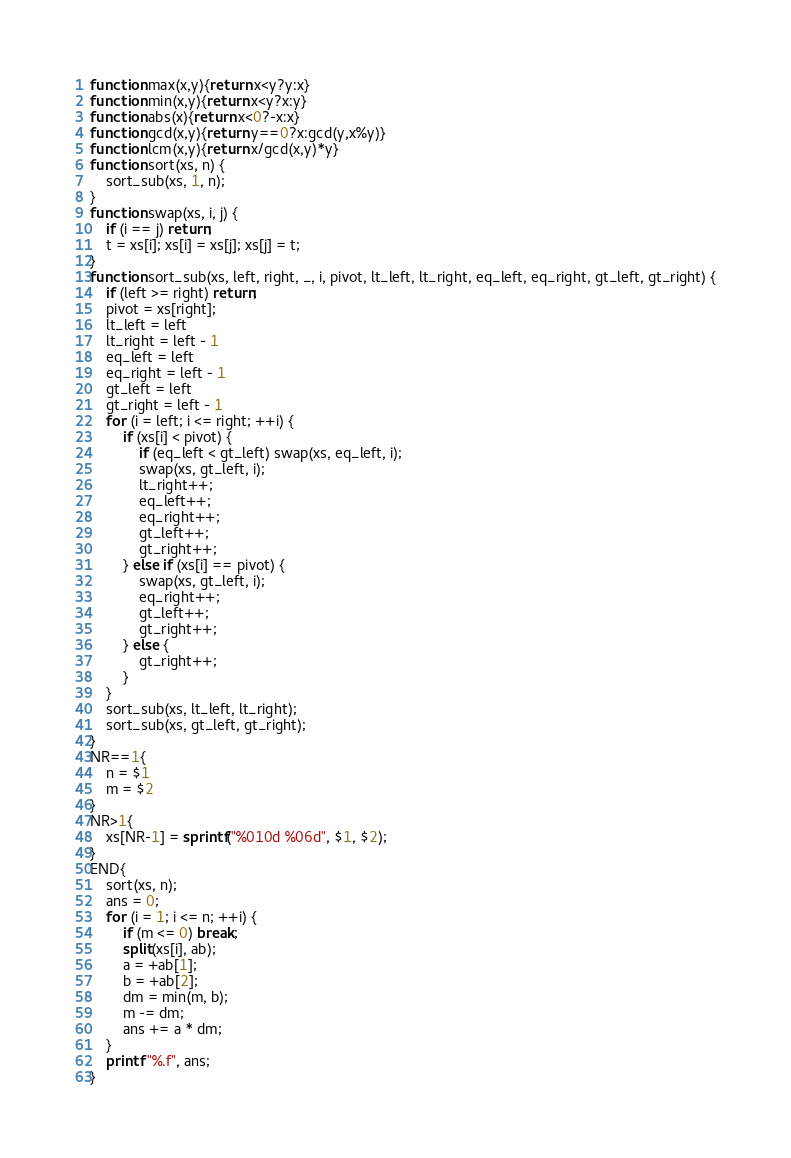Convert code to text. <code><loc_0><loc_0><loc_500><loc_500><_Awk_>function max(x,y){return x<y?y:x}
function min(x,y){return x<y?x:y}
function abs(x){return x<0?-x:x}
function gcd(x,y){return y==0?x:gcd(y,x%y)}
function lcm(x,y){return x/gcd(x,y)*y}
function sort(xs, n) {
    sort_sub(xs, 1, n);
}
function swap(xs, i, j) {
    if (i == j) return;
    t = xs[i]; xs[i] = xs[j]; xs[j] = t;
}
function sort_sub(xs, left, right, _, i, pivot, lt_left, lt_right, eq_left, eq_right, gt_left, gt_right) {
    if (left >= right) return;
    pivot = xs[right];
    lt_left = left
    lt_right = left - 1
    eq_left = left
    eq_right = left - 1
    gt_left = left
    gt_right = left - 1
    for (i = left; i <= right; ++i) {
        if (xs[i] < pivot) {
            if (eq_left < gt_left) swap(xs, eq_left, i);
            swap(xs, gt_left, i);
            lt_right++;
            eq_left++;
            eq_right++;
            gt_left++;
            gt_right++;
        } else if (xs[i] == pivot) {
            swap(xs, gt_left, i);
            eq_right++;
            gt_left++;
            gt_right++;
        } else {
            gt_right++;
        }
    }
    sort_sub(xs, lt_left, lt_right);
    sort_sub(xs, gt_left, gt_right);
}
NR==1{
    n = $1
    m = $2
}
NR>1{
    xs[NR-1] = sprintf("%010d %06d", $1, $2);
}
END{
    sort(xs, n);
    ans = 0;
    for (i = 1; i <= n; ++i) {
        if (m <= 0) break;
        split(xs[i], ab);
        a = +ab[1];
        b = +ab[2];
        dm = min(m, b);
        m -= dm;
        ans += a * dm;
    }
    printf "%.f", ans;
}
</code> 